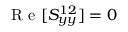Convert formula to latex. <formula><loc_0><loc_0><loc_500><loc_500>R e [ S _ { y y } ^ { 1 2 } ] = 0</formula> 